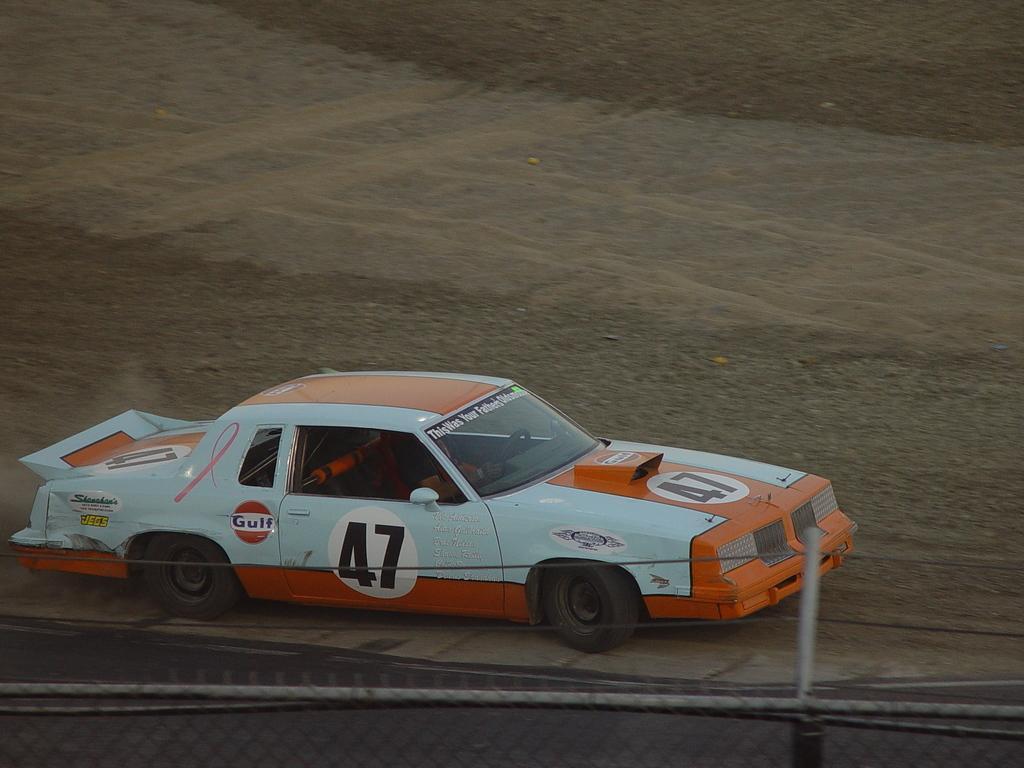How would you summarize this image in a sentence or two? In this picture there is a man who is sitting inside the car and he is riding on the road. At the bottom I can see the fencing. At the door of the car I can see the number forty seven. 